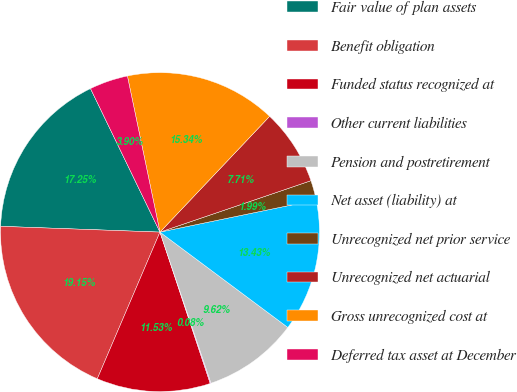Convert chart to OTSL. <chart><loc_0><loc_0><loc_500><loc_500><pie_chart><fcel>Fair value of plan assets<fcel>Benefit obligation<fcel>Funded status recognized at<fcel>Other current liabilities<fcel>Pension and postretirement<fcel>Net asset (liability) at<fcel>Unrecognized net prior service<fcel>Unrecognized net actuarial<fcel>Gross unrecognized cost at<fcel>Deferred tax asset at December<nl><fcel>17.25%<fcel>19.15%<fcel>11.53%<fcel>0.08%<fcel>9.62%<fcel>13.43%<fcel>1.99%<fcel>7.71%<fcel>15.34%<fcel>3.9%<nl></chart> 